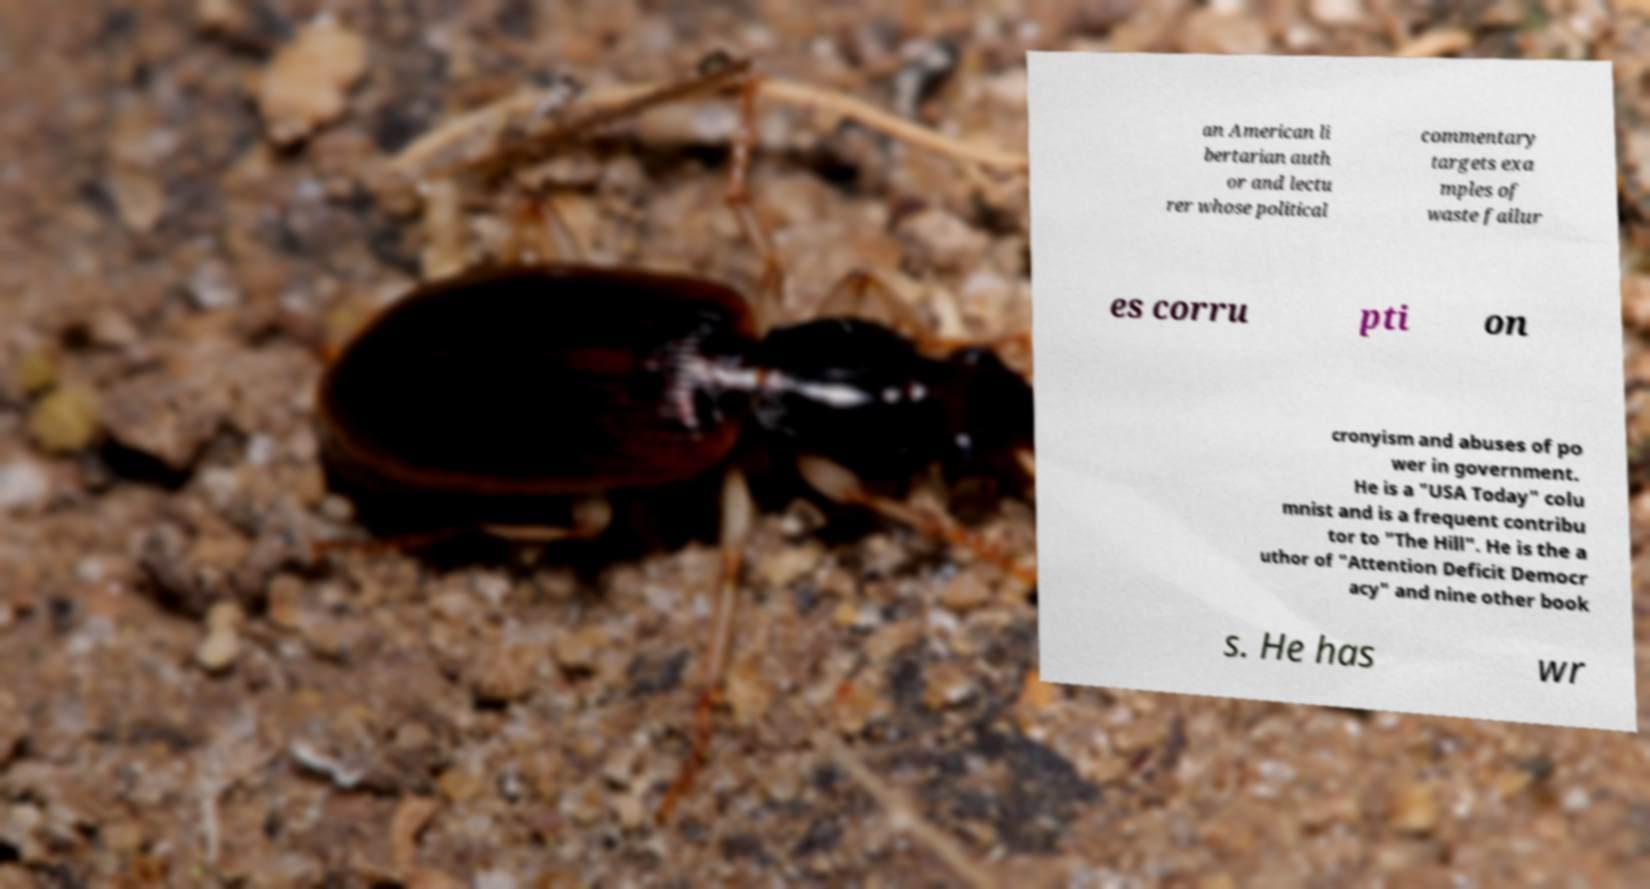Could you assist in decoding the text presented in this image and type it out clearly? an American li bertarian auth or and lectu rer whose political commentary targets exa mples of waste failur es corru pti on cronyism and abuses of po wer in government. He is a "USA Today" colu mnist and is a frequent contribu tor to "The Hill". He is the a uthor of "Attention Deficit Democr acy" and nine other book s. He has wr 